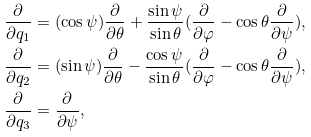<formula> <loc_0><loc_0><loc_500><loc_500>\frac { \partial } { \partial q _ { 1 } } & = ( \cos \psi ) \frac { \partial } { \partial \theta } + \frac { \sin \psi } { \sin \theta } ( \frac { \partial } { \partial \varphi } - \cos \theta \frac { \partial } { \partial \psi } ) , \\ \frac { \partial } { \partial q _ { 2 } } & = ( \sin \psi ) \frac { \partial } { \partial \theta } - \frac { \cos \psi } { \sin \theta } ( \frac { \partial } { \partial \varphi } - \cos \theta \frac { \partial } { \partial \psi } ) , \\ \frac { \partial } { \partial q _ { 3 } } & = \frac { \partial } { \partial \psi } ,</formula> 